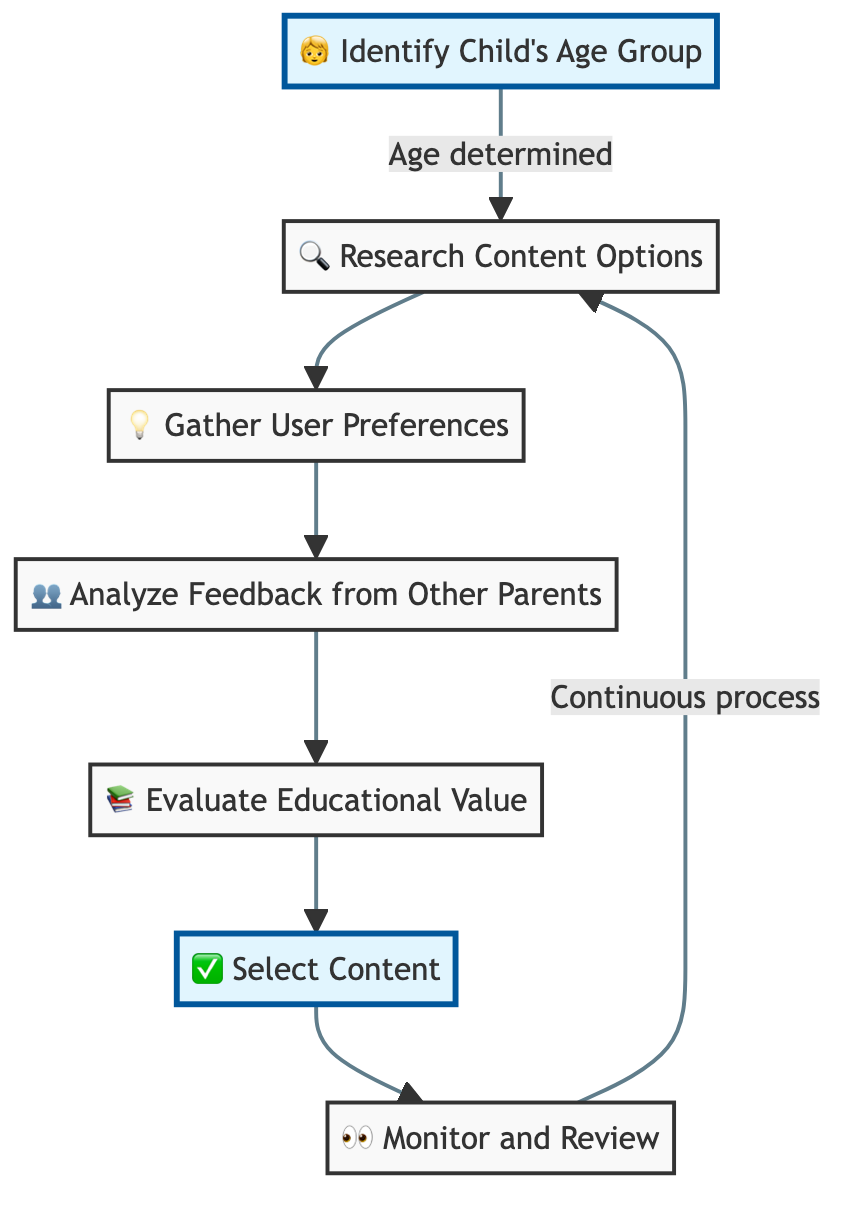What is the first step in the decision-making process? The first step indicated in the flowchart is to "Identify Child's Age Group." This node is positioned at the beginning of the flow and clearly labeled as the starting point of the process.
Answer: Identify Child's Age Group How many total nodes are present in the flowchart? By counting each distinct step in the flowchart, including both highlighted and regular nodes, we find there are seven nodes in total.
Answer: 7 What step follows after researching content options? The flowchart shows that after "Research Content Options," the next step is "Gather User Preferences," which is directly connected to the previous node in the flow.
Answer: Gather User Preferences What is the purpose of evaluating educational value? The diagram indicates that the purpose of "Evaluate Educational Value" is to assess the learning outcomes and skills development promoted by the content, making that the reason for this node's inclusion.
Answer: Assess learning outcomes What is the final step in the process? The last step in the flowchart is "Monitor and Review," which concludes the series of actions for selecting age-appropriate digital content and reflects ongoing observation and feedback.
Answer: Monitor and Review How does the process ensure continuous improvement? The diagram illustrates that "Monitor and Review" connects back to "Research Content Options," indicating that user feedback and continuous observation lead to revisiting content options for further enhancing the selection process over time.
Answer: By revisiting content options What type of feedback is analyzed in the decision-making process? The flowchart specifies that the feedback analyzed is from "other parents," which encompasses their ratings, reviews, and testimonials regarding specific digital content.
Answer: Other parents What decision is made at the "Select Content" node? At the "Select Content" node, the decision involves making an informed choice based on age appropriateness, user preferences, and educational value, as illustrated by its connection to the previous nodes.
Answer: An informed decision Which node emphasizes the child's interests? "Gather User Preferences" specifically emphasizes collecting data on the child's interests and preferred genres, making it clear that user preferences play a key role in the selection process.
Answer: Gather User Preferences 